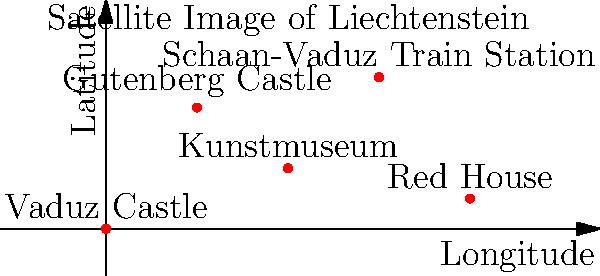Based on the satellite imagery of Liechtenstein shown above, which tourist attraction is located at the highest latitude? To determine which tourist attraction is at the highest latitude, we need to follow these steps:

1. Understand that latitude is represented on the y-axis of the graph.
2. Compare the y-coordinates of each location:
   - Vaduz Castle: y ≈ 0
   - Gutenberg Castle: y ≈ 40
   - Kunstmuseum: y ≈ 20
   - Schaan-Vaduz Train Station: y ≈ 50
   - Red House: y ≈ 10

3. Identify the highest y-coordinate, which corresponds to the highest latitude.
4. The highest y-coordinate is approximately 50, corresponding to the Schaan-Vaduz Train Station.

Therefore, based on this satellite imagery representation, the Schaan-Vaduz Train Station is located at the highest latitude among the given tourist attractions in Liechtenstein.
Answer: Schaan-Vaduz Train Station 